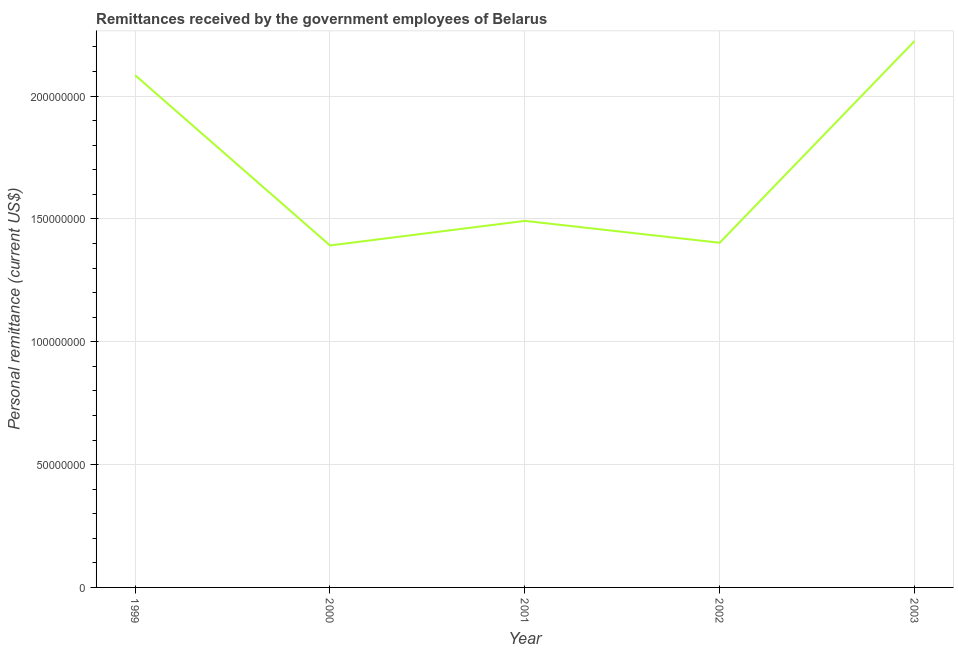What is the personal remittances in 1999?
Your answer should be very brief. 2.08e+08. Across all years, what is the maximum personal remittances?
Provide a short and direct response. 2.22e+08. Across all years, what is the minimum personal remittances?
Your response must be concise. 1.39e+08. In which year was the personal remittances maximum?
Provide a succinct answer. 2003. What is the sum of the personal remittances?
Offer a very short reply. 8.60e+08. What is the difference between the personal remittances in 2001 and 2002?
Provide a succinct answer. 8.90e+06. What is the average personal remittances per year?
Keep it short and to the point. 1.72e+08. What is the median personal remittances?
Offer a terse response. 1.49e+08. What is the ratio of the personal remittances in 2001 to that in 2003?
Provide a succinct answer. 0.67. Is the personal remittances in 2000 less than that in 2003?
Your answer should be very brief. Yes. Is the difference between the personal remittances in 2001 and 2002 greater than the difference between any two years?
Your answer should be compact. No. What is the difference between the highest and the second highest personal remittances?
Provide a short and direct response. 1.39e+07. Is the sum of the personal remittances in 1999 and 2001 greater than the maximum personal remittances across all years?
Make the answer very short. Yes. What is the difference between the highest and the lowest personal remittances?
Give a very brief answer. 8.32e+07. In how many years, is the personal remittances greater than the average personal remittances taken over all years?
Your answer should be compact. 2. How many lines are there?
Your response must be concise. 1. Does the graph contain any zero values?
Provide a short and direct response. No. Does the graph contain grids?
Ensure brevity in your answer.  Yes. What is the title of the graph?
Provide a succinct answer. Remittances received by the government employees of Belarus. What is the label or title of the X-axis?
Provide a short and direct response. Year. What is the label or title of the Y-axis?
Provide a succinct answer. Personal remittance (current US$). What is the Personal remittance (current US$) of 1999?
Make the answer very short. 2.08e+08. What is the Personal remittance (current US$) of 2000?
Make the answer very short. 1.39e+08. What is the Personal remittance (current US$) of 2001?
Provide a short and direct response. 1.49e+08. What is the Personal remittance (current US$) of 2002?
Your answer should be very brief. 1.40e+08. What is the Personal remittance (current US$) of 2003?
Provide a short and direct response. 2.22e+08. What is the difference between the Personal remittance (current US$) in 1999 and 2000?
Offer a very short reply. 6.93e+07. What is the difference between the Personal remittance (current US$) in 1999 and 2001?
Your answer should be very brief. 5.93e+07. What is the difference between the Personal remittance (current US$) in 1999 and 2002?
Your response must be concise. 6.82e+07. What is the difference between the Personal remittance (current US$) in 1999 and 2003?
Your answer should be compact. -1.39e+07. What is the difference between the Personal remittance (current US$) in 2000 and 2001?
Offer a terse response. -1.00e+07. What is the difference between the Personal remittance (current US$) in 2000 and 2002?
Provide a short and direct response. -1.10e+06. What is the difference between the Personal remittance (current US$) in 2000 and 2003?
Your response must be concise. -8.32e+07. What is the difference between the Personal remittance (current US$) in 2001 and 2002?
Your answer should be compact. 8.90e+06. What is the difference between the Personal remittance (current US$) in 2001 and 2003?
Your response must be concise. -7.32e+07. What is the difference between the Personal remittance (current US$) in 2002 and 2003?
Your answer should be compact. -8.21e+07. What is the ratio of the Personal remittance (current US$) in 1999 to that in 2000?
Your answer should be compact. 1.5. What is the ratio of the Personal remittance (current US$) in 1999 to that in 2001?
Ensure brevity in your answer.  1.4. What is the ratio of the Personal remittance (current US$) in 1999 to that in 2002?
Give a very brief answer. 1.49. What is the ratio of the Personal remittance (current US$) in 1999 to that in 2003?
Provide a succinct answer. 0.94. What is the ratio of the Personal remittance (current US$) in 2000 to that in 2001?
Give a very brief answer. 0.93. What is the ratio of the Personal remittance (current US$) in 2000 to that in 2003?
Your response must be concise. 0.63. What is the ratio of the Personal remittance (current US$) in 2001 to that in 2002?
Offer a very short reply. 1.06. What is the ratio of the Personal remittance (current US$) in 2001 to that in 2003?
Your answer should be compact. 0.67. What is the ratio of the Personal remittance (current US$) in 2002 to that in 2003?
Provide a succinct answer. 0.63. 